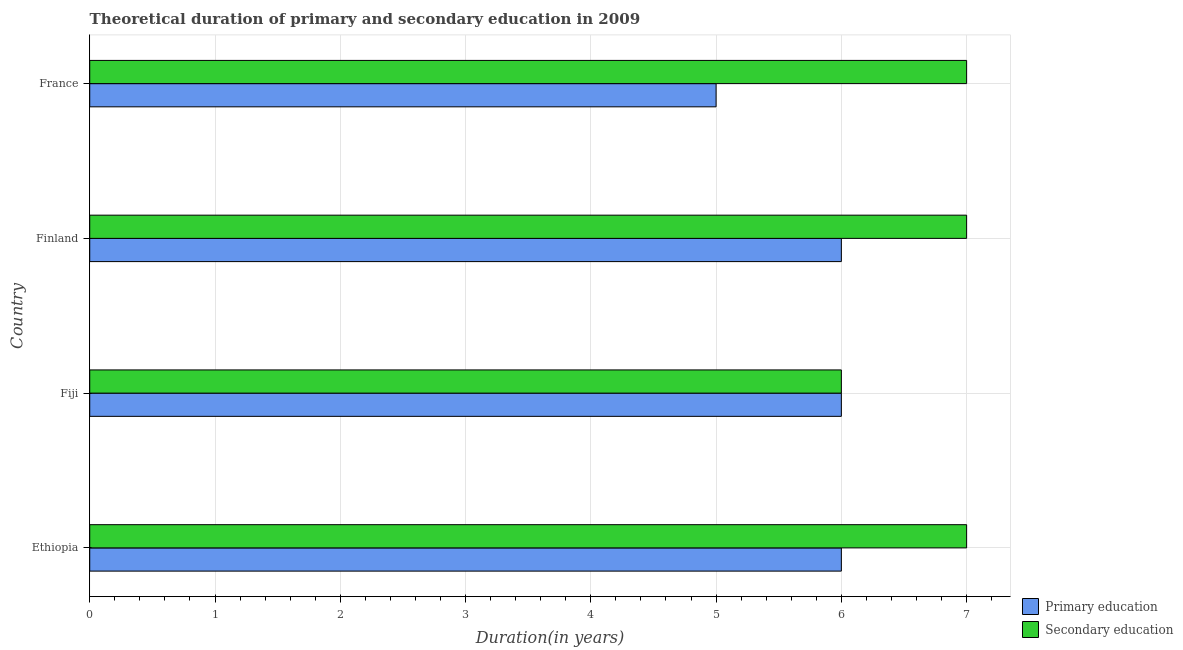How many bars are there on the 2nd tick from the top?
Keep it short and to the point. 2. How many bars are there on the 4th tick from the bottom?
Provide a short and direct response. 2. What is the label of the 3rd group of bars from the top?
Make the answer very short. Fiji. In how many cases, is the number of bars for a given country not equal to the number of legend labels?
Your response must be concise. 0. What is the duration of primary education in Fiji?
Provide a short and direct response. 6. Across all countries, what is the minimum duration of primary education?
Make the answer very short. 5. In which country was the duration of secondary education maximum?
Keep it short and to the point. Ethiopia. In which country was the duration of secondary education minimum?
Provide a succinct answer. Fiji. What is the total duration of secondary education in the graph?
Make the answer very short. 27. What is the difference between the duration of secondary education in Ethiopia and that in Fiji?
Make the answer very short. 1. What is the difference between the duration of secondary education in Ethiopia and the duration of primary education in Finland?
Your response must be concise. 1. What is the average duration of primary education per country?
Keep it short and to the point. 5.75. What is the difference between the duration of primary education and duration of secondary education in Finland?
Offer a very short reply. -1. What is the difference between the highest and the second highest duration of primary education?
Ensure brevity in your answer.  0. What is the difference between the highest and the lowest duration of primary education?
Provide a succinct answer. 1. What does the 2nd bar from the top in Finland represents?
Offer a very short reply. Primary education. What does the 2nd bar from the bottom in Fiji represents?
Provide a short and direct response. Secondary education. Are all the bars in the graph horizontal?
Ensure brevity in your answer.  Yes. How many countries are there in the graph?
Your answer should be very brief. 4. What is the difference between two consecutive major ticks on the X-axis?
Make the answer very short. 1. Does the graph contain grids?
Keep it short and to the point. Yes. Where does the legend appear in the graph?
Ensure brevity in your answer.  Bottom right. What is the title of the graph?
Make the answer very short. Theoretical duration of primary and secondary education in 2009. What is the label or title of the X-axis?
Keep it short and to the point. Duration(in years). What is the Duration(in years) of Primary education in Ethiopia?
Provide a succinct answer. 6. What is the Duration(in years) in Secondary education in Ethiopia?
Your answer should be very brief. 7. What is the Duration(in years) of Secondary education in Fiji?
Your response must be concise. 6. What is the Duration(in years) of Primary education in Finland?
Offer a terse response. 6. What is the Duration(in years) of Secondary education in Finland?
Provide a short and direct response. 7. What is the Duration(in years) of Primary education in France?
Your answer should be very brief. 5. Across all countries, what is the minimum Duration(in years) in Secondary education?
Offer a terse response. 6. What is the total Duration(in years) in Primary education in the graph?
Ensure brevity in your answer.  23. What is the difference between the Duration(in years) in Primary education in Ethiopia and that in Fiji?
Your answer should be very brief. 0. What is the difference between the Duration(in years) of Secondary education in Ethiopia and that in Fiji?
Your answer should be very brief. 1. What is the difference between the Duration(in years) of Primary education in Ethiopia and that in Finland?
Your answer should be very brief. 0. What is the difference between the Duration(in years) in Secondary education in Ethiopia and that in Finland?
Your answer should be very brief. 0. What is the difference between the Duration(in years) in Primary education in Ethiopia and that in France?
Offer a terse response. 1. What is the difference between the Duration(in years) of Secondary education in Ethiopia and that in France?
Your response must be concise. 0. What is the difference between the Duration(in years) of Primary education in Fiji and that in Finland?
Your answer should be very brief. 0. What is the difference between the Duration(in years) of Secondary education in Fiji and that in Finland?
Your answer should be compact. -1. What is the difference between the Duration(in years) in Secondary education in Fiji and that in France?
Make the answer very short. -1. What is the difference between the Duration(in years) in Primary education in Finland and that in France?
Make the answer very short. 1. What is the difference between the Duration(in years) in Primary education in Fiji and the Duration(in years) in Secondary education in Finland?
Ensure brevity in your answer.  -1. What is the difference between the Duration(in years) in Primary education in Fiji and the Duration(in years) in Secondary education in France?
Your answer should be compact. -1. What is the difference between the Duration(in years) of Primary education in Finland and the Duration(in years) of Secondary education in France?
Offer a very short reply. -1. What is the average Duration(in years) of Primary education per country?
Offer a very short reply. 5.75. What is the average Duration(in years) in Secondary education per country?
Your answer should be very brief. 6.75. What is the difference between the Duration(in years) in Primary education and Duration(in years) in Secondary education in Ethiopia?
Provide a short and direct response. -1. What is the ratio of the Duration(in years) of Primary education in Ethiopia to that in Finland?
Your answer should be compact. 1. What is the ratio of the Duration(in years) of Primary education in Ethiopia to that in France?
Keep it short and to the point. 1.2. What is the ratio of the Duration(in years) in Secondary education in Ethiopia to that in France?
Keep it short and to the point. 1. What is the ratio of the Duration(in years) of Primary education in Fiji to that in Finland?
Provide a short and direct response. 1. What is the ratio of the Duration(in years) in Secondary education in Fiji to that in Finland?
Offer a very short reply. 0.86. What is the ratio of the Duration(in years) in Primary education in Fiji to that in France?
Your response must be concise. 1.2. What is the ratio of the Duration(in years) of Primary education in Finland to that in France?
Make the answer very short. 1.2. What is the ratio of the Duration(in years) of Secondary education in Finland to that in France?
Offer a terse response. 1. 